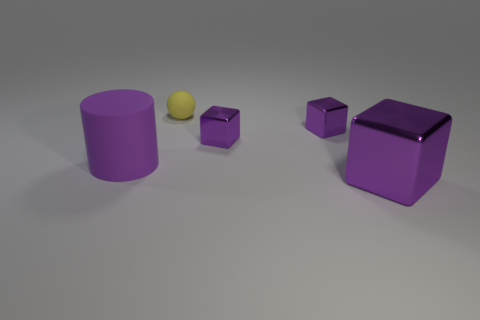Can you tell me the colors of the objects in the image? Sure! In the image, there are purple objects, which include a cylinder and two cubes, and there's a small yellow sphere. 